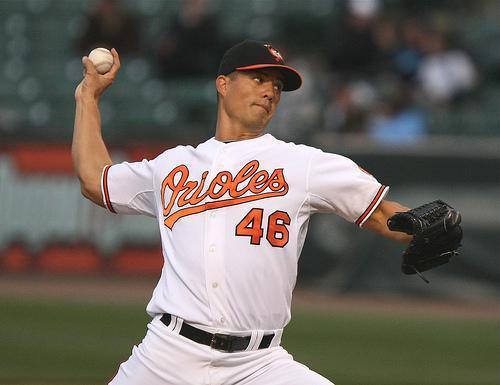How many people are clearly visible?
Give a very brief answer. 1. 